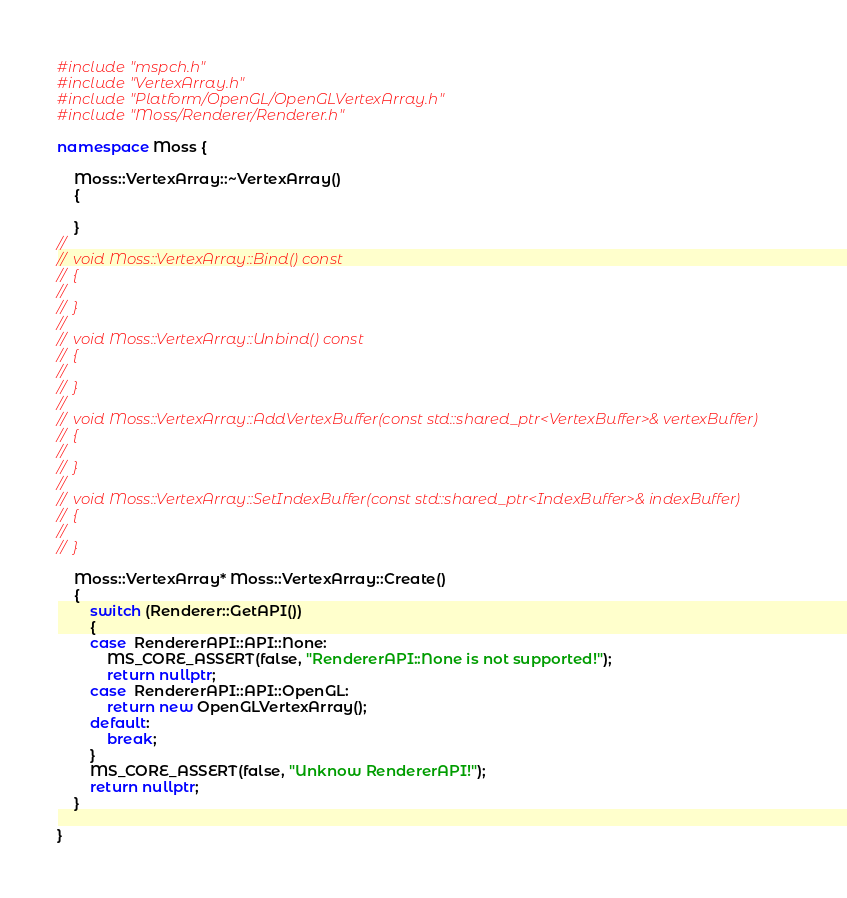<code> <loc_0><loc_0><loc_500><loc_500><_C++_>#include "mspch.h"
#include "VertexArray.h"
#include "Platform/OpenGL/OpenGLVertexArray.h"
#include "Moss/Renderer/Renderer.h"

namespace Moss {

	Moss::VertexArray::~VertexArray()
	{

	}
// 
// 	void Moss::VertexArray::Bind() const
// 	{
// 
// 	}
// 
// 	void Moss::VertexArray::Unbind() const
// 	{
// 
// 	}
// 
// 	void Moss::VertexArray::AddVertexBuffer(const std::shared_ptr<VertexBuffer>& vertexBuffer)
// 	{
// 
// 	}
// 
// 	void Moss::VertexArray::SetIndexBuffer(const std::shared_ptr<IndexBuffer>& indexBuffer)
// 	{
// 
// 	}

	Moss::VertexArray* Moss::VertexArray::Create()
	{
		switch (Renderer::GetAPI())
		{
		case  RendererAPI::API::None:
			MS_CORE_ASSERT(false, "RendererAPI::None is not supported!");
			return nullptr;
		case  RendererAPI::API::OpenGL:
			return new OpenGLVertexArray();
		default:
			break;
		}
		MS_CORE_ASSERT(false, "Unknow RendererAPI!");
		return nullptr;
	}

}
</code> 